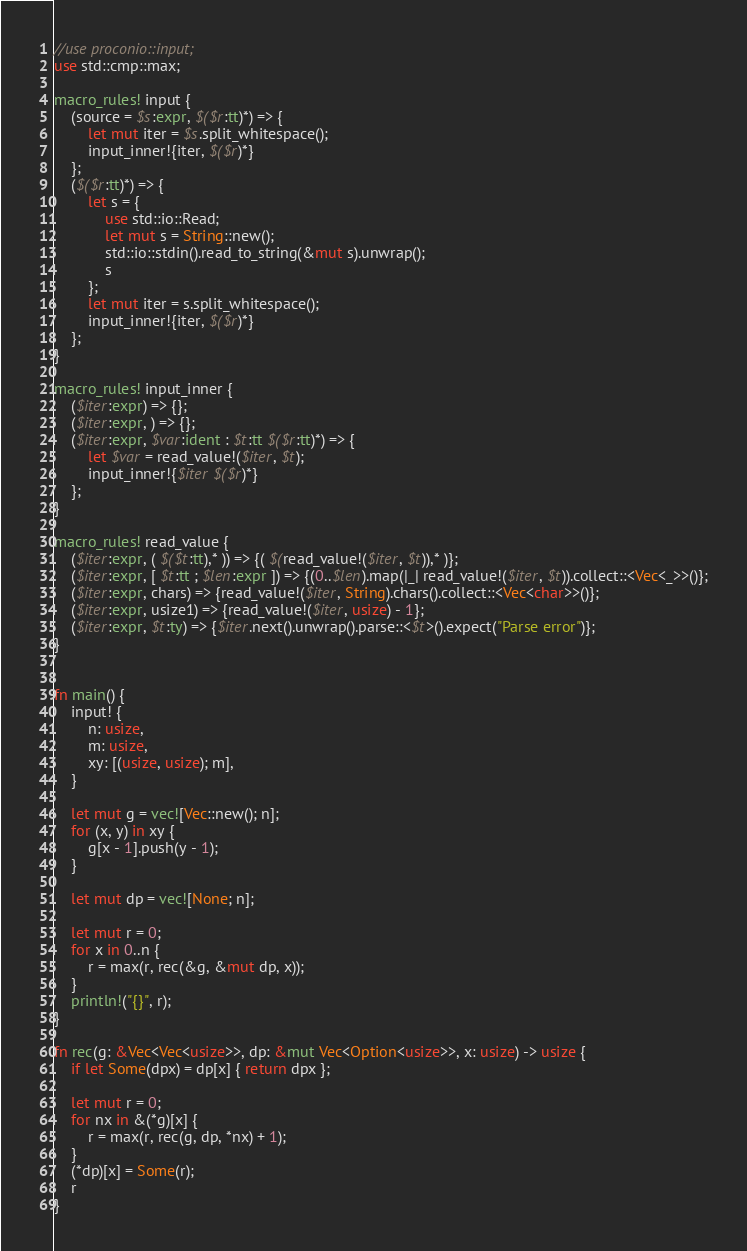<code> <loc_0><loc_0><loc_500><loc_500><_Rust_>//use proconio::input;
use std::cmp::max;

macro_rules! input {
    (source = $s:expr, $($r:tt)*) => {
        let mut iter = $s.split_whitespace();
        input_inner!{iter, $($r)*}
    };
    ($($r:tt)*) => {
        let s = {
            use std::io::Read;
            let mut s = String::new();
            std::io::stdin().read_to_string(&mut s).unwrap();
            s
        };
        let mut iter = s.split_whitespace();
        input_inner!{iter, $($r)*}
    };
}

macro_rules! input_inner {
    ($iter:expr) => {};
    ($iter:expr, ) => {};
    ($iter:expr, $var:ident : $t:tt $($r:tt)*) => {
        let $var = read_value!($iter, $t);
        input_inner!{$iter $($r)*}
    };
}

macro_rules! read_value {
    ($iter:expr, ( $($t:tt),* )) => {( $(read_value!($iter, $t)),* )};
    ($iter:expr, [ $t:tt ; $len:expr ]) => {(0..$len).map(|_| read_value!($iter, $t)).collect::<Vec<_>>()};
    ($iter:expr, chars) => {read_value!($iter, String).chars().collect::<Vec<char>>()};
    ($iter:expr, usize1) => {read_value!($iter, usize) - 1};
    ($iter:expr, $t:ty) => {$iter.next().unwrap().parse::<$t>().expect("Parse error")};
}


fn main() {
    input! {
        n: usize,
        m: usize,
        xy: [(usize, usize); m],
    }

    let mut g = vec![Vec::new(); n];
    for (x, y) in xy {
        g[x - 1].push(y - 1);
    }

    let mut dp = vec![None; n];

    let mut r = 0;
    for x in 0..n {
        r = max(r, rec(&g, &mut dp, x));
    }
    println!("{}", r);
}

fn rec(g: &Vec<Vec<usize>>, dp: &mut Vec<Option<usize>>, x: usize) -> usize {
    if let Some(dpx) = dp[x] { return dpx };

    let mut r = 0;
    for nx in &(*g)[x] {
        r = max(r, rec(g, dp, *nx) + 1);
    }
    (*dp)[x] = Some(r);
    r
}</code> 